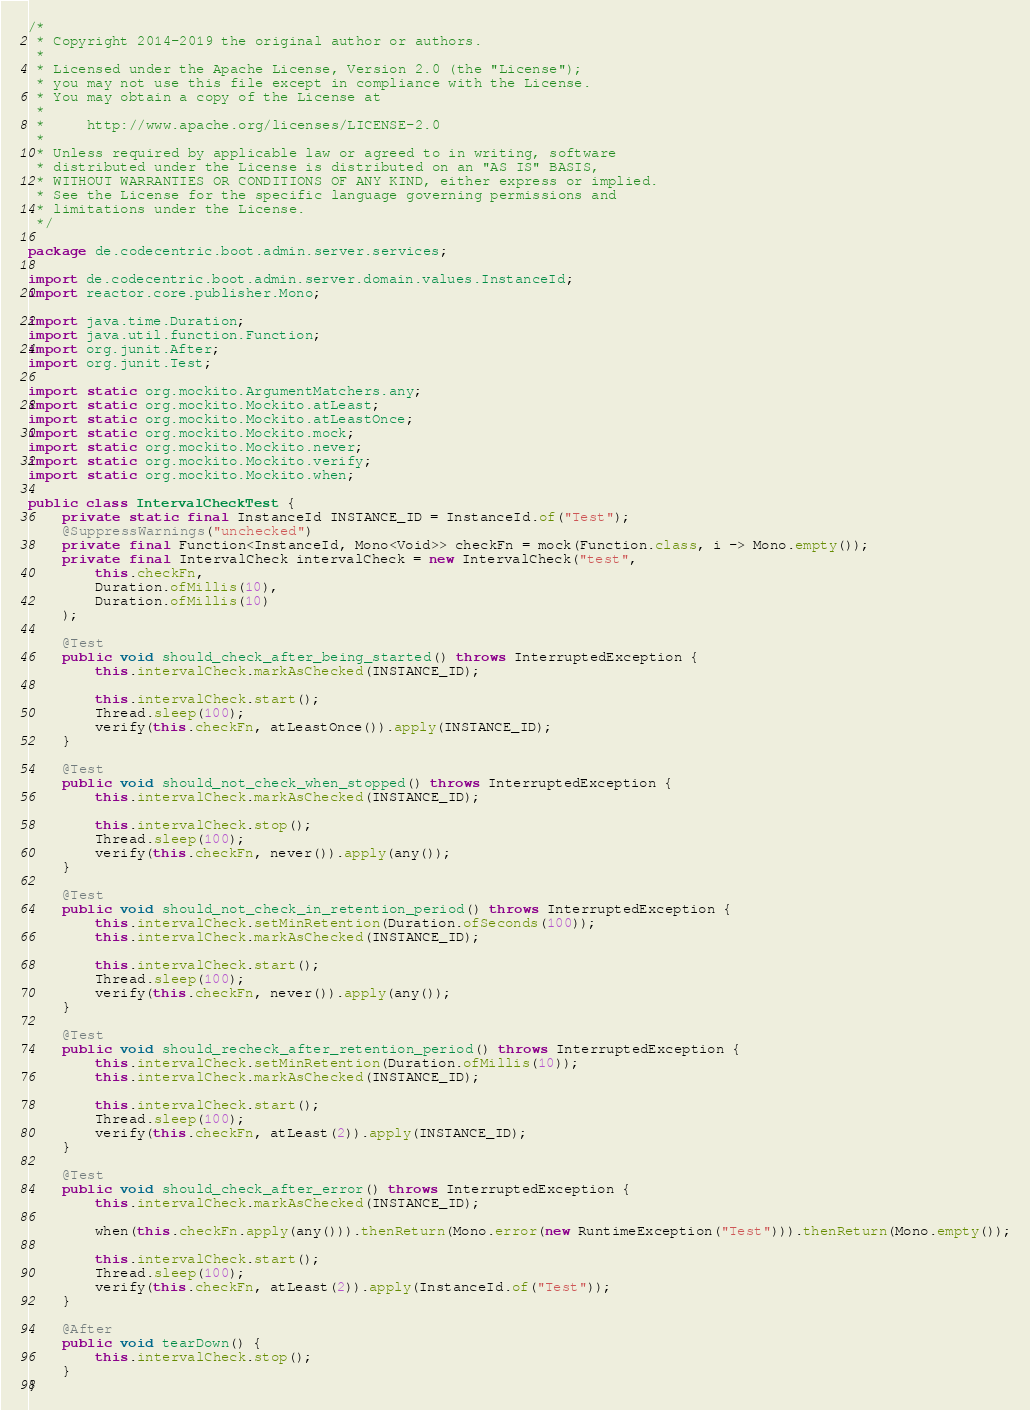<code> <loc_0><loc_0><loc_500><loc_500><_Java_>/*
 * Copyright 2014-2019 the original author or authors.
 *
 * Licensed under the Apache License, Version 2.0 (the "License");
 * you may not use this file except in compliance with the License.
 * You may obtain a copy of the License at
 *
 *     http://www.apache.org/licenses/LICENSE-2.0
 *
 * Unless required by applicable law or agreed to in writing, software
 * distributed under the License is distributed on an "AS IS" BASIS,
 * WITHOUT WARRANTIES OR CONDITIONS OF ANY KIND, either express or implied.
 * See the License for the specific language governing permissions and
 * limitations under the License.
 */

package de.codecentric.boot.admin.server.services;

import de.codecentric.boot.admin.server.domain.values.InstanceId;
import reactor.core.publisher.Mono;

import java.time.Duration;
import java.util.function.Function;
import org.junit.After;
import org.junit.Test;

import static org.mockito.ArgumentMatchers.any;
import static org.mockito.Mockito.atLeast;
import static org.mockito.Mockito.atLeastOnce;
import static org.mockito.Mockito.mock;
import static org.mockito.Mockito.never;
import static org.mockito.Mockito.verify;
import static org.mockito.Mockito.when;

public class IntervalCheckTest {
    private static final InstanceId INSTANCE_ID = InstanceId.of("Test");
    @SuppressWarnings("unchecked")
    private final Function<InstanceId, Mono<Void>> checkFn = mock(Function.class, i -> Mono.empty());
    private final IntervalCheck intervalCheck = new IntervalCheck("test",
        this.checkFn,
        Duration.ofMillis(10),
        Duration.ofMillis(10)
    );

    @Test
    public void should_check_after_being_started() throws InterruptedException {
        this.intervalCheck.markAsChecked(INSTANCE_ID);

        this.intervalCheck.start();
        Thread.sleep(100);
        verify(this.checkFn, atLeastOnce()).apply(INSTANCE_ID);
    }

    @Test
    public void should_not_check_when_stopped() throws InterruptedException {
        this.intervalCheck.markAsChecked(INSTANCE_ID);

        this.intervalCheck.stop();
        Thread.sleep(100);
        verify(this.checkFn, never()).apply(any());
    }

    @Test
    public void should_not_check_in_retention_period() throws InterruptedException {
        this.intervalCheck.setMinRetention(Duration.ofSeconds(100));
        this.intervalCheck.markAsChecked(INSTANCE_ID);

        this.intervalCheck.start();
        Thread.sleep(100);
        verify(this.checkFn, never()).apply(any());
    }

    @Test
    public void should_recheck_after_retention_period() throws InterruptedException {
        this.intervalCheck.setMinRetention(Duration.ofMillis(10));
        this.intervalCheck.markAsChecked(INSTANCE_ID);

        this.intervalCheck.start();
        Thread.sleep(100);
        verify(this.checkFn, atLeast(2)).apply(INSTANCE_ID);
    }

    @Test
    public void should_check_after_error() throws InterruptedException {
        this.intervalCheck.markAsChecked(INSTANCE_ID);

        when(this.checkFn.apply(any())).thenReturn(Mono.error(new RuntimeException("Test"))).thenReturn(Mono.empty());

        this.intervalCheck.start();
        Thread.sleep(100);
        verify(this.checkFn, atLeast(2)).apply(InstanceId.of("Test"));
    }

    @After
    public void tearDown() {
        this.intervalCheck.stop();
    }
}
</code> 